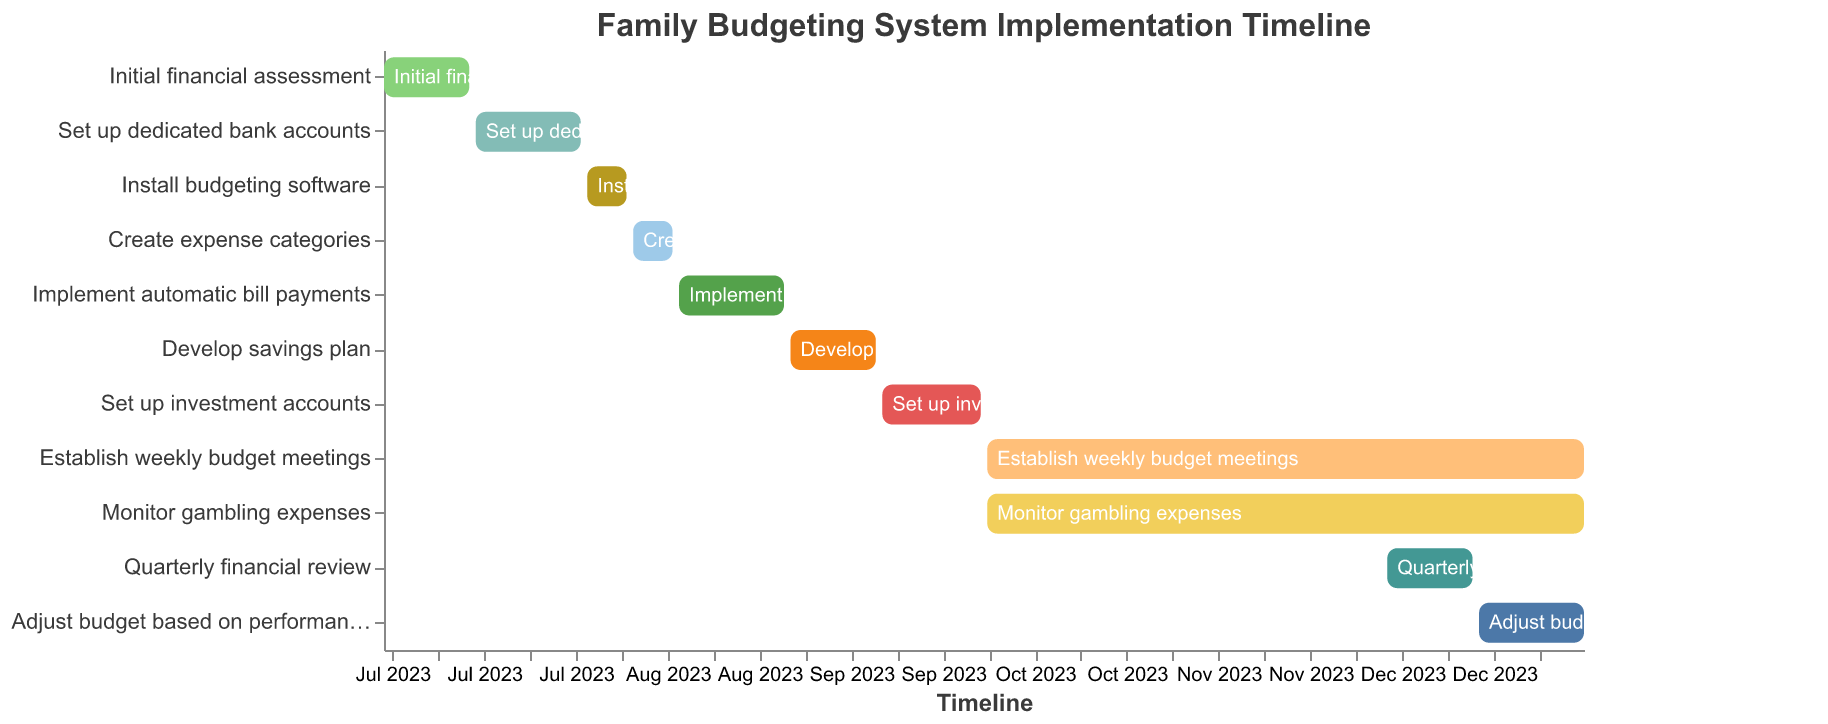How many tasks are scheduled to start in August? There are three tasks scheduled to start in August: "Install budgeting software" on August 1, "Create expense categories" on August 8, and "Implement automatic bill payments" on August 15.
Answer: 3 Which task takes the longest duration to complete? The "Establish weekly budget meetings" and "Monitor gambling expenses" both take the longest duration to complete, ranging from October 1 to December 31, covering almost three months.
Answer: Establish weekly budget meetings and Monitor gambling expenses What is the time gap between the end of "Create expense categories" and the start of "Implement automatic bill payments"? "Create expense categories" ends on August 14 and "Implement automatic bill payments" starts on August 15, so there is a 1-day gap between these tasks.
Answer: 1 day Which tasks overlap in the month of December? In December, "Establish weekly budget meetings," "Monitor gambling expenses," "Quarterly financial review," and "Adjust budget based on performance" overlap.
Answer: Establish weekly budget meetings, Monitor gambling expenses, Quarterly financial review, and Adjust budget based on performance What tasks are set to be completed within September? The tasks set to be completed within September are "Develop savings plan" (September 1 to September 14) and "Set up investment accounts" (September 15 to September 30).
Answer: Develop savings plan and Set up investment accounts How many tasks are scheduled to start before September? There are five tasks scheduled to start before September: "Initial financial assessment," "Set up dedicated bank accounts," "Install budgeting software," "Create expense categories," and "Implement automatic bill payments."
Answer: 5 What is the duration of the "Initial financial assessment" task? The "Initial financial assessment" task starts on July 1 and ends on July 14, covering a duration of 14 days.
Answer: 14 days Which tasks start on the same date and what is that date? Both "Establish weekly budget meetings" and "Monitor gambling expenses" start on October 1.
Answer: October 1 What is the primary focus of the tasks starting in October? The primary focus of the tasks starting in October is on monitoring and consistent financial practices, as seen in tasks such as "Establish weekly budget meetings" and "Monitor gambling expenses."
Answer: Monitoring and consistent financial practices 